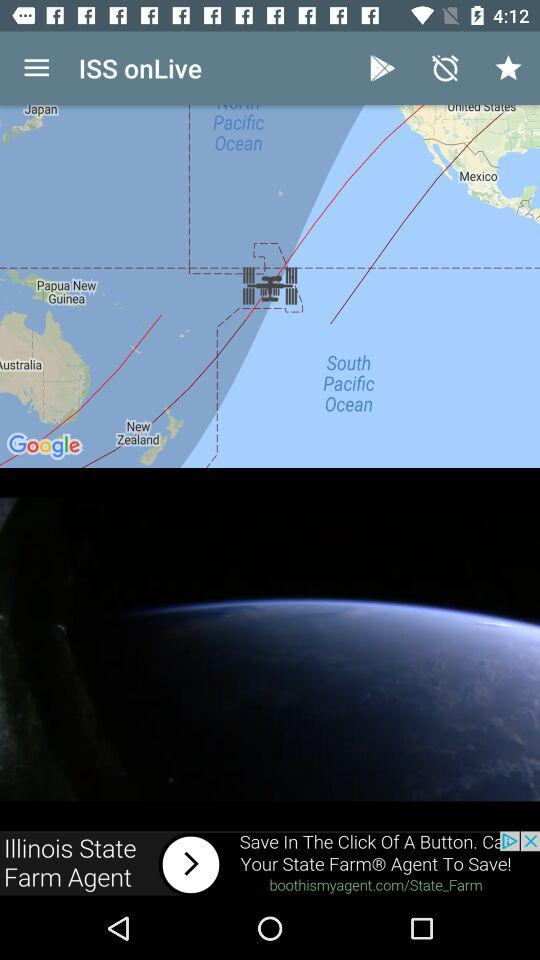How many updates were announced?
Answer the question using a single word or phrase. 2 